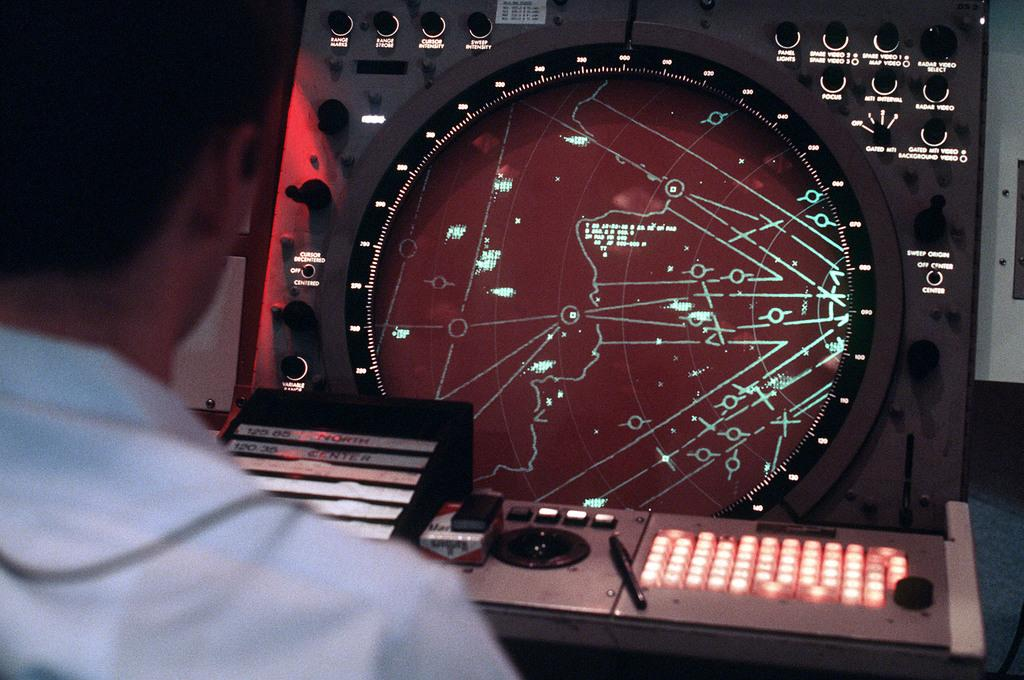Who or what is present in the image? There is a person in the image. What else can be seen in the image besides the person? There is a machine with switches and a pen on a surface in the image. Is there a slope in the image that the person is trying to climb? There is no slope present in the image. 